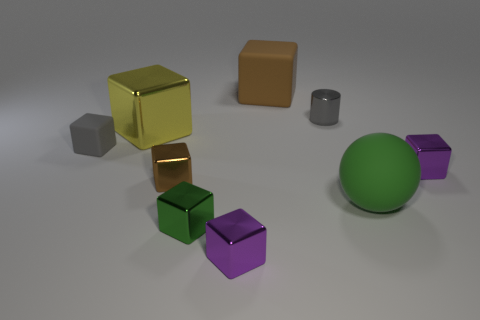Subtract 4 blocks. How many blocks are left? 3 Subtract all big matte cubes. How many cubes are left? 6 Subtract all yellow blocks. How many blocks are left? 6 Add 1 small matte objects. How many objects exist? 10 Subtract all brown cubes. Subtract all green cylinders. How many cubes are left? 5 Subtract all cylinders. How many objects are left? 8 Subtract all big matte objects. Subtract all tiny cylinders. How many objects are left? 6 Add 4 large metallic cubes. How many large metallic cubes are left? 5 Add 9 big matte cubes. How many big matte cubes exist? 10 Subtract 0 blue cylinders. How many objects are left? 9 